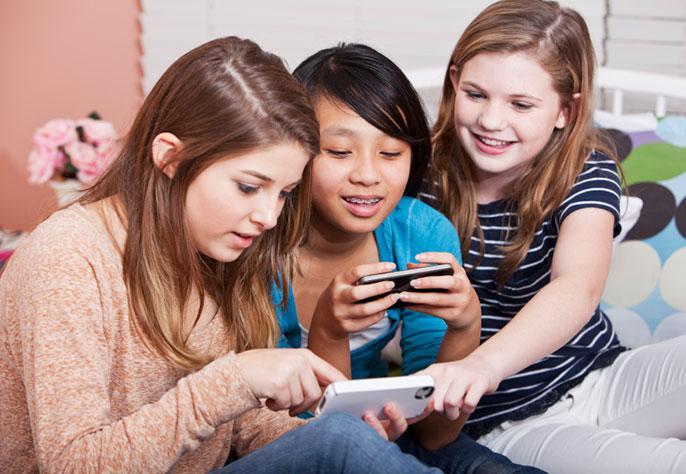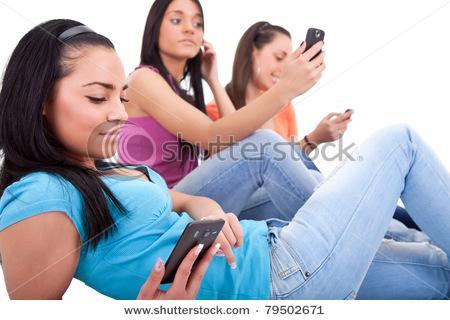The first image is the image on the left, the second image is the image on the right. Assess this claim about the two images: "The left image contains a row of exactly three girls, and each girl is looking at a phone, but not every girl is holding a phone.". Correct or not? Answer yes or no. Yes. The first image is the image on the left, the second image is the image on the right. Evaluate the accuracy of this statement regarding the images: "The left and right image contains the same number of people on their phones.". Is it true? Answer yes or no. Yes. 